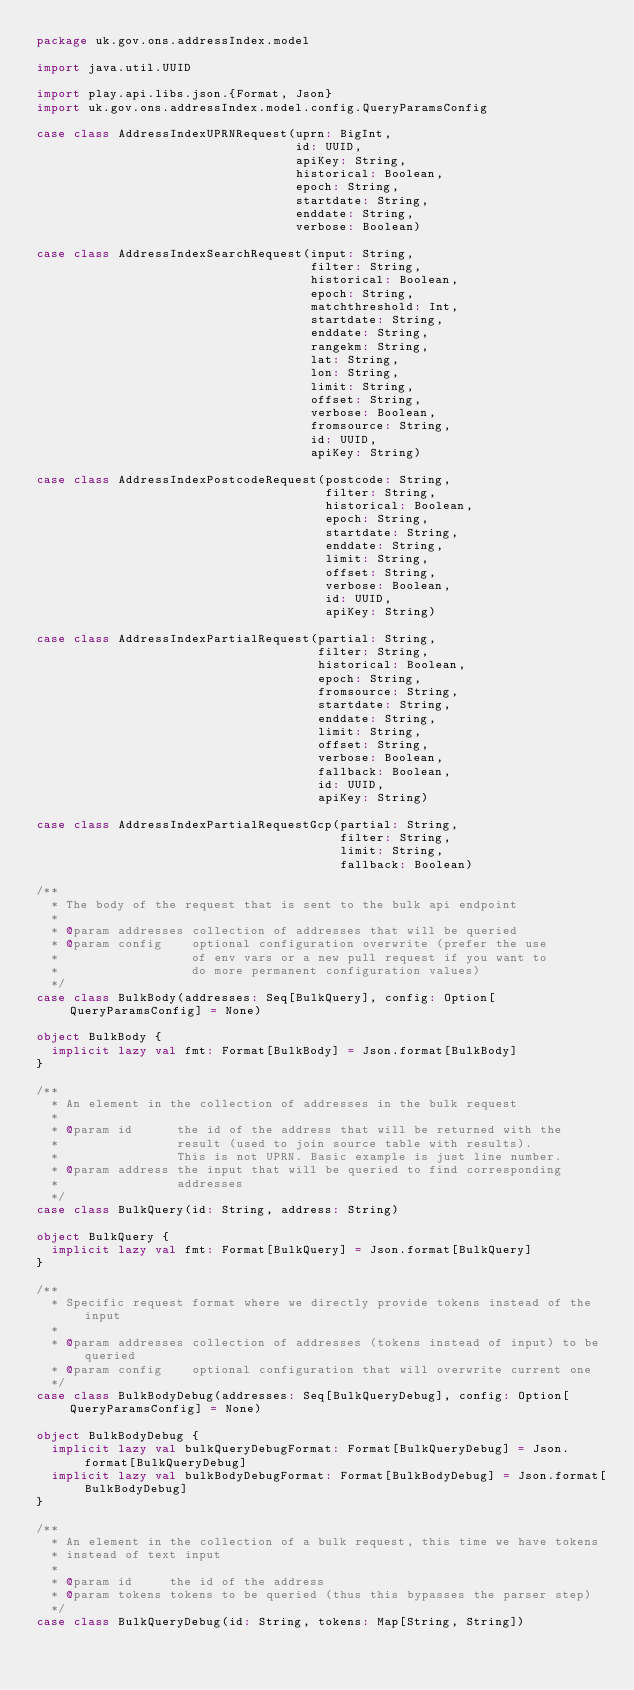Convert code to text. <code><loc_0><loc_0><loc_500><loc_500><_Scala_>package uk.gov.ons.addressIndex.model

import java.util.UUID

import play.api.libs.json.{Format, Json}
import uk.gov.ons.addressIndex.model.config.QueryParamsConfig

case class AddressIndexUPRNRequest(uprn: BigInt,
                                   id: UUID,
                                   apiKey: String,
                                   historical: Boolean,
                                   epoch: String,
                                   startdate: String,
                                   enddate: String,
                                   verbose: Boolean)

case class AddressIndexSearchRequest(input: String,
                                     filter: String,
                                     historical: Boolean,
                                     epoch: String,
                                     matchthreshold: Int,
                                     startdate: String,
                                     enddate: String,
                                     rangekm: String,
                                     lat: String,
                                     lon: String,
                                     limit: String,
                                     offset: String,
                                     verbose: Boolean,
                                     fromsource: String,
                                     id: UUID,
                                     apiKey: String)

case class AddressIndexPostcodeRequest(postcode: String,
                                       filter: String,
                                       historical: Boolean,
                                       epoch: String,
                                       startdate: String,
                                       enddate: String,
                                       limit: String,
                                       offset: String,
                                       verbose: Boolean,
                                       id: UUID,
                                       apiKey: String)

case class AddressIndexPartialRequest(partial: String,
                                      filter: String,
                                      historical: Boolean,
                                      epoch: String,
                                      fromsource: String,
                                      startdate: String,
                                      enddate: String,
                                      limit: String,
                                      offset: String,
                                      verbose: Boolean,
                                      fallback: Boolean,
                                      id: UUID,
                                      apiKey: String)

case class AddressIndexPartialRequestGcp(partial: String,
                                         filter: String,
                                         limit: String,
                                         fallback: Boolean)

/**
  * The body of the request that is sent to the bulk api endpoint
  *
  * @param addresses collection of addresses that will be queried
  * @param config    optional configuration overwrite (prefer the use
  *                  of env vars or a new pull request if you want to
  *                  do more permanent configuration values)
  */
case class BulkBody(addresses: Seq[BulkQuery], config: Option[QueryParamsConfig] = None)

object BulkBody {
  implicit lazy val fmt: Format[BulkBody] = Json.format[BulkBody]
}

/**
  * An element in the collection of addresses in the bulk request
  *
  * @param id      the id of the address that will be returned with the
  *                result (used to join source table with results).
  *                This is not UPRN. Basic example is just line number.
  * @param address the input that will be queried to find corresponding
  *                addresses
  */
case class BulkQuery(id: String, address: String)

object BulkQuery {
  implicit lazy val fmt: Format[BulkQuery] = Json.format[BulkQuery]
}

/**
  * Specific request format where we directly provide tokens instead of the input
  *
  * @param addresses collection of addresses (tokens instead of input) to be queried
  * @param config    optional configuration that will overwrite current one
  */
case class BulkBodyDebug(addresses: Seq[BulkQueryDebug], config: Option[QueryParamsConfig] = None)

object BulkBodyDebug {
  implicit lazy val bulkQueryDebugFormat: Format[BulkQueryDebug] = Json.format[BulkQueryDebug]
  implicit lazy val bulkBodyDebugFormat: Format[BulkBodyDebug] = Json.format[BulkBodyDebug]
}

/**
  * An element in the collection of a bulk request, this time we have tokens
  * instead of text input
  *
  * @param id     the id of the address
  * @param tokens tokens to be queried (thus this bypasses the parser step)
  */
case class BulkQueryDebug(id: String, tokens: Map[String, String])
</code> 